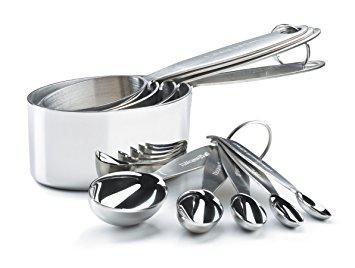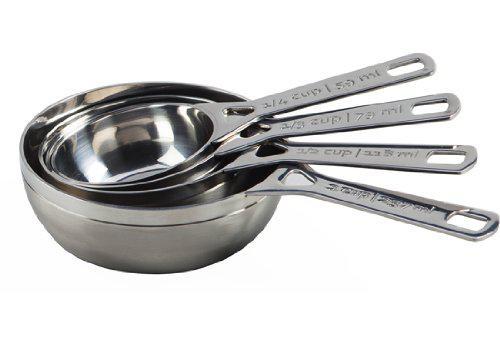The first image is the image on the left, the second image is the image on the right. For the images shown, is this caption "There are five measuring cups in the right image" true? Answer yes or no. No. 